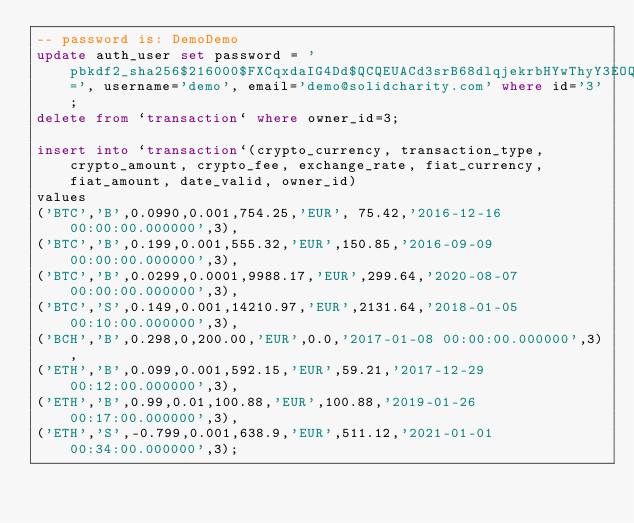<code> <loc_0><loc_0><loc_500><loc_500><_SQL_>-- password is: DemoDemo
update auth_user set password = 'pbkdf2_sha256$216000$FXCqxdaIG4Dd$QCQEUACd3srB68dlqjekrbHYwThyY3EOQxctr6u0hYQ=', username='demo', email='demo@solidcharity.com' where id='3';
delete from `transaction` where owner_id=3;

insert into `transaction`(crypto_currency, transaction_type, crypto_amount, crypto_fee, exchange_rate, fiat_currency, fiat_amount, date_valid, owner_id)
values 
('BTC','B',0.0990,0.001,754.25,'EUR', 75.42,'2016-12-16 00:00:00.000000',3),
('BTC','B',0.199,0.001,555.32,'EUR',150.85,'2016-09-09 00:00:00.000000',3),
('BTC','B',0.0299,0.0001,9988.17,'EUR',299.64,'2020-08-07 00:00:00.000000',3),
('BTC','S',0.149,0.001,14210.97,'EUR',2131.64,'2018-01-05 00:10:00.000000',3),
('BCH','B',0.298,0,200.00,'EUR',0.0,'2017-01-08 00:00:00.000000',3),
('ETH','B',0.099,0.001,592.15,'EUR',59.21,'2017-12-29 00:12:00.000000',3),
('ETH','B',0.99,0.01,100.88,'EUR',100.88,'2019-01-26 00:17:00.000000',3),
('ETH','S',-0.799,0.001,638.9,'EUR',511.12,'2021-01-01 00:34:00.000000',3);
</code> 